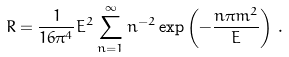Convert formula to latex. <formula><loc_0><loc_0><loc_500><loc_500>R = \frac { 1 } { 1 6 \pi ^ { 4 } } E ^ { 2 } \sum _ { n = 1 } ^ { \infty } n ^ { - 2 } \exp \left ( - \frac { n \pi m ^ { 2 } } { E } \right ) \, .</formula> 